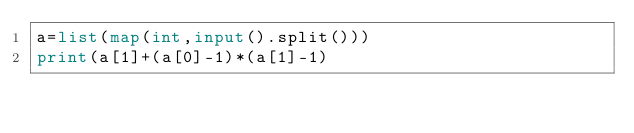<code> <loc_0><loc_0><loc_500><loc_500><_Python_>a=list(map(int,input().split()))
print(a[1]+(a[0]-1)*(a[1]-1)</code> 